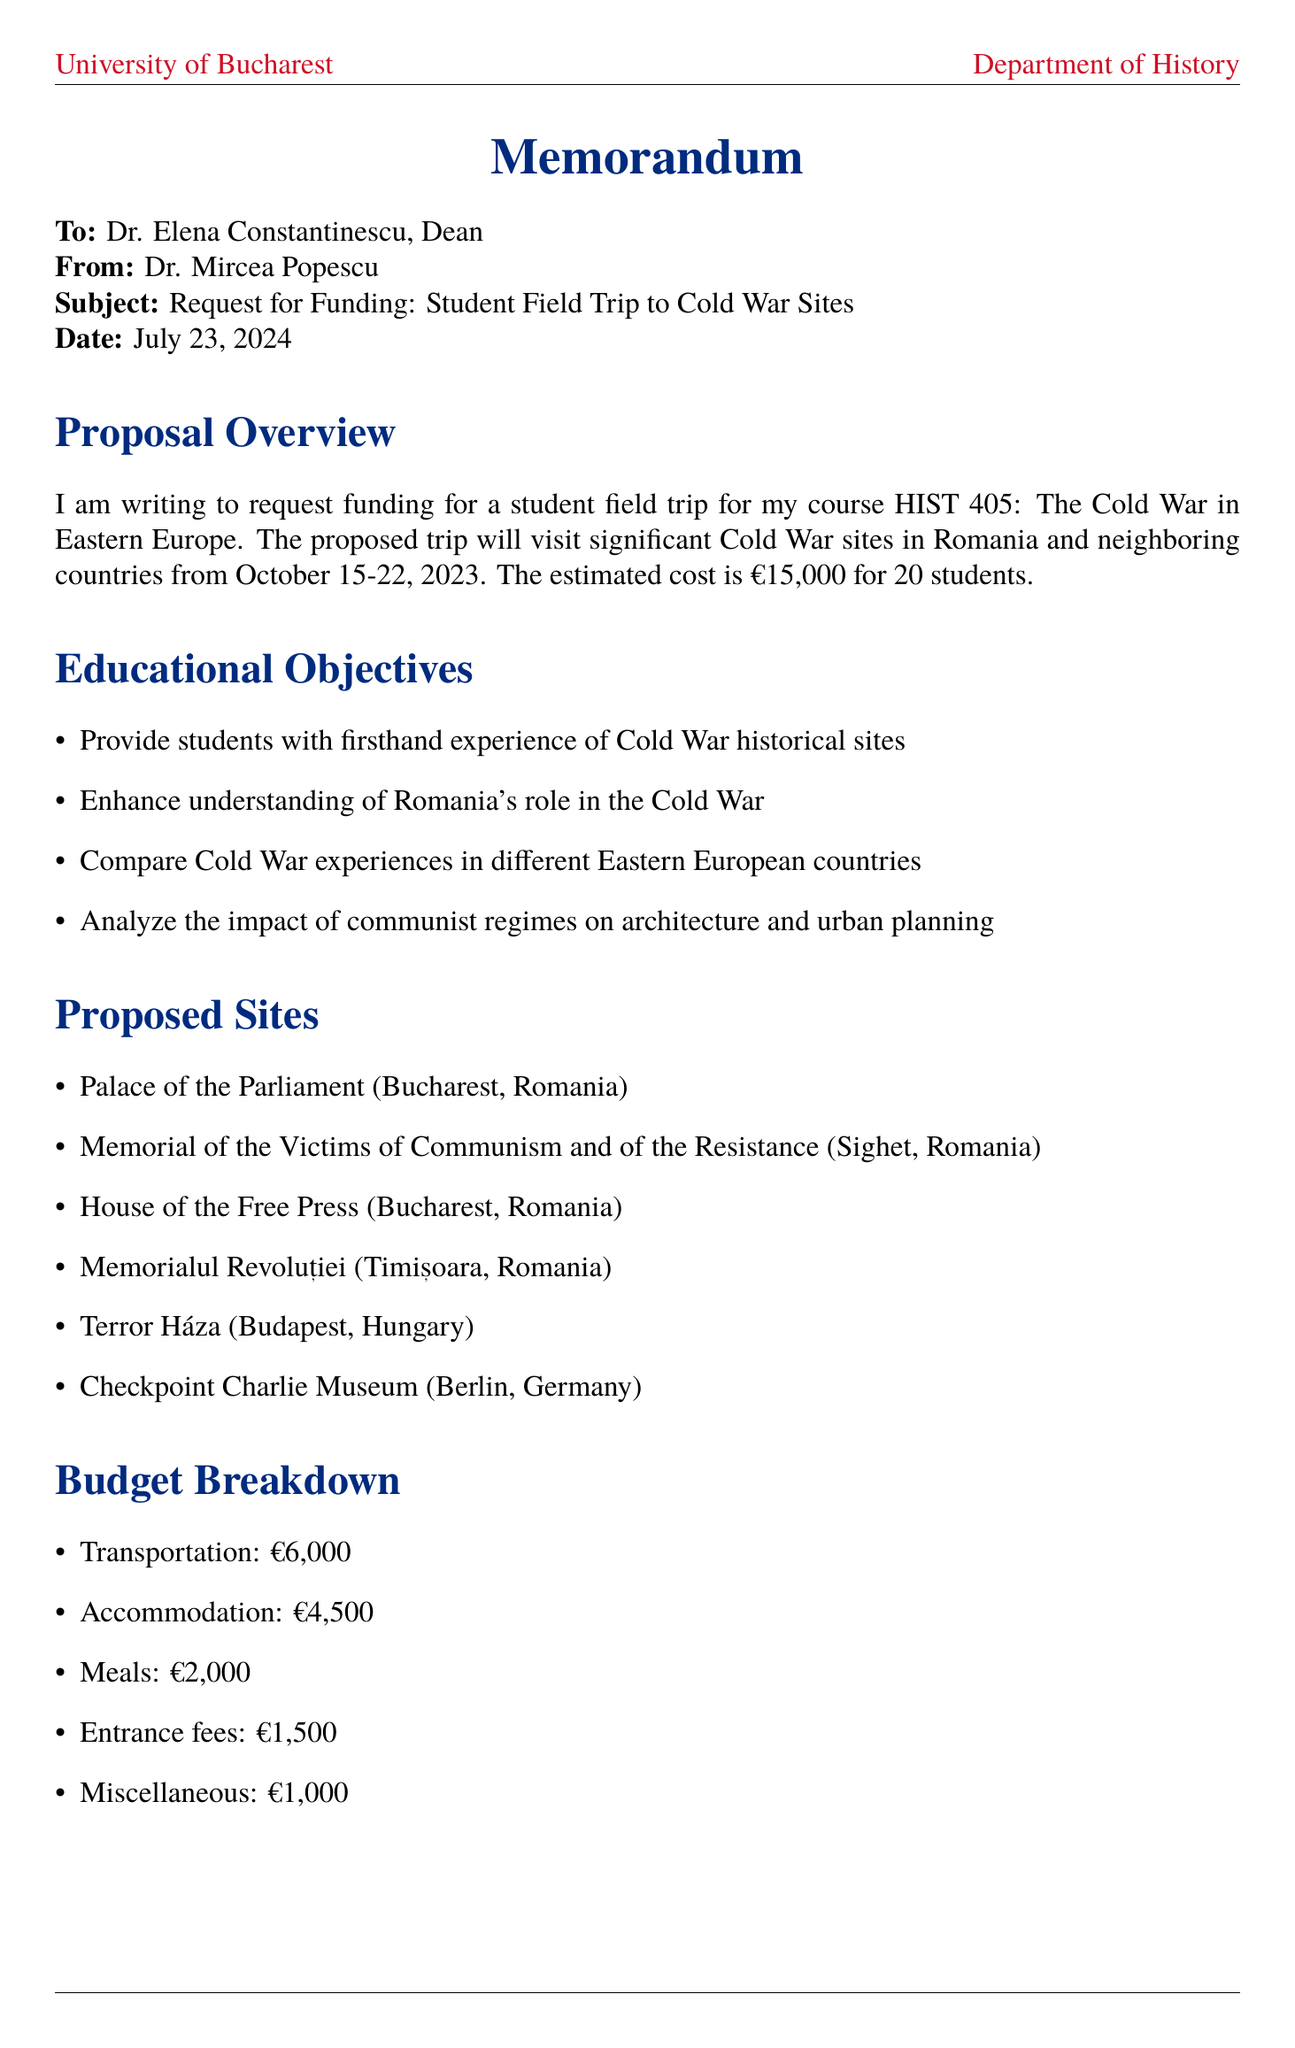What is the title of the memo? The title of the memo is specified at the beginning, outlining the main subject of the request.
Answer: Request for Funding: Student Field Trip to Cold War Sites in Romania and Neighboring Countries Who is the professor requesting the funding? The professor's name is presented in the header portion of the document, indicating the author of the memo.
Answer: Dr. Mircea Popescu What are the proposed dates for the field trip? The proposed dates are included in the overview section of the memo, providing details on the timing of the trip.
Answer: October 15-22, 2023 How many students will participate in the trip? This number is specified in the overview and highlights the scale of the proposed field trip.
Answer: 20 Which site in Budapest is included in the trip? The site listed under proposed sites provides insight into the geographical location of the planned trip.
Answer: Terror Háza (House of Terror) What is the estimated cost of the trip? The total cost for the trip is mentioned in the overview to justify the funding request.
Answer: €15,000 What is one of the educational objectives of the trip? An objective is clearly listed in the educational objectives section to explain the purpose of the trip.
Answer: Provide students with firsthand experience of Cold War historical sites What supports the university's commitment in this proposal? Supporting arguments listed in the memo detail how the trip aligns with the university's educational goals.
Answer: Aligns with university's commitment to experiential learning What prior success is mentioned in relation to the department's trips? Previous successes highlight the outcomes of past activities, reinforcing the effectiveness of such trips.
Answer: 2019 field trip to Soviet-era sites in Moldova resulted in two published student papers 